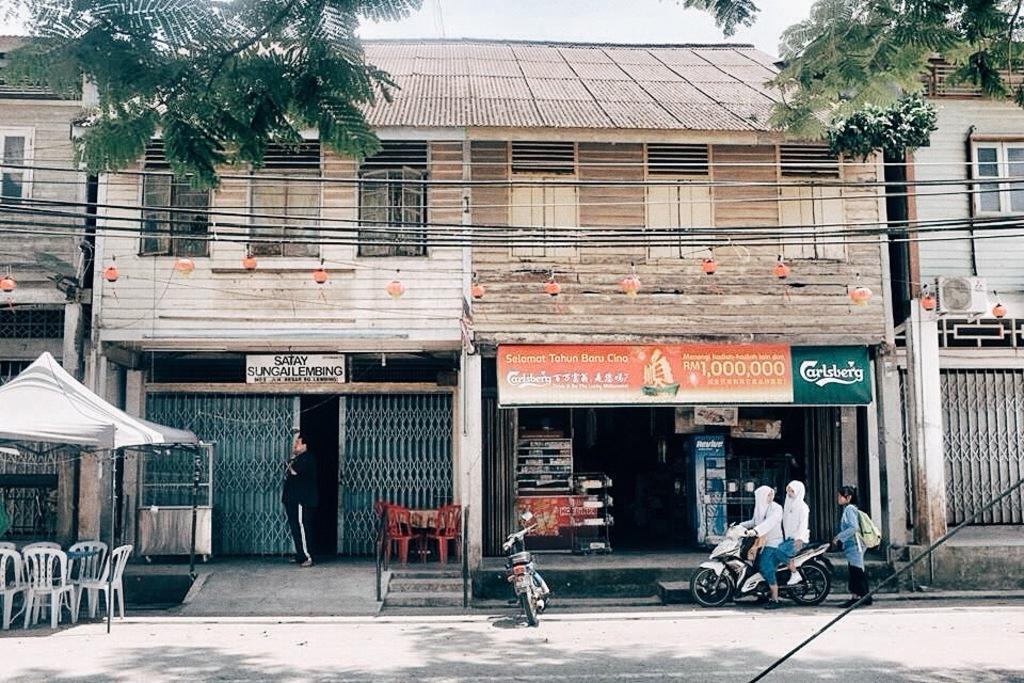How would you summarize this image in a sentence or two? At the bottom of the image on the road there are two motorcycles. There are two persons sitting on a motorcycle. Behind them there is a person standing. On the left side of the image there are chairs and also there is a table and a tent. Behind them there are buildings with walls, windows, roofs, pillars, gates and also there is an air conditioner. And also there is a store with few things in it and also there are boards with names on it. 